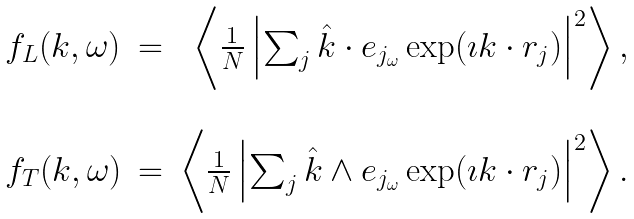Convert formula to latex. <formula><loc_0><loc_0><loc_500><loc_500>\begin{array} { l r r } f _ { L } ( k , \omega ) & = & \left \langle \frac { 1 } { N } \left | \sum _ { j } { \hat { k } } \cdot { e } _ { j _ { \omega } } \exp ( \imath { k } \cdot { r } _ { j } ) \right | ^ { 2 } \right \rangle , \\ & & \\ f _ { T } ( k , \omega ) & = & \left \langle \frac { 1 } { N } \left | \sum _ { j } { \hat { k } } \wedge { e } _ { j _ { \omega } } \exp ( \imath { k } \cdot { r } _ { j } ) \right | ^ { 2 } \right \rangle . \end{array}</formula> 